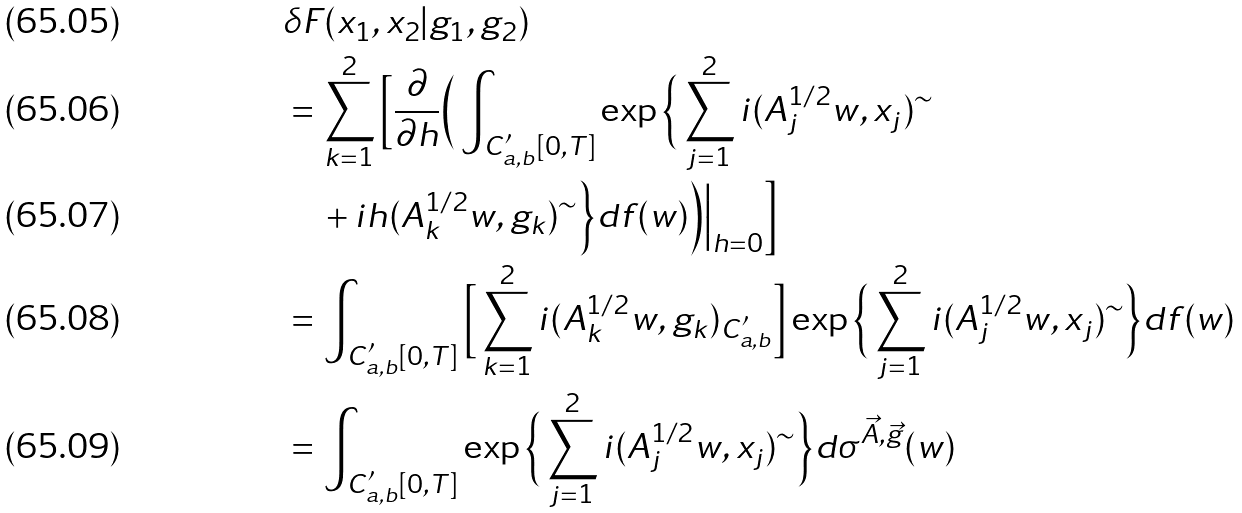Convert formula to latex. <formula><loc_0><loc_0><loc_500><loc_500>& \delta F ( x _ { 1 } , x _ { 2 } | g _ { 1 } , g _ { 2 } ) \\ & = \sum _ { k = 1 } ^ { 2 } \Big [ \frac { \partial } { \partial h } \Big ( \int _ { C _ { a , b } ^ { \prime } [ 0 , T ] } \exp \Big \{ \sum _ { j = 1 } ^ { 2 } i ( A _ { j } ^ { 1 / 2 } w , x _ { j } ) ^ { \sim } \\ & \quad + i h ( A _ { k } ^ { 1 / 2 } w , g _ { k } ) ^ { \sim } \Big \} d f ( w ) \Big ) \Big | _ { h = 0 } \Big ] \\ & = \int _ { C _ { a , b } ^ { \prime } [ 0 , T ] } \Big [ \sum _ { k = 1 } ^ { 2 } i ( A _ { k } ^ { 1 / 2 } w , g _ { k } ) _ { C _ { a , b } ^ { \prime } } \Big ] \exp \Big \{ \sum _ { j = 1 } ^ { 2 } i ( A _ { j } ^ { 1 / 2 } w , x _ { j } ) ^ { \sim } \Big \} d f ( w ) \\ & = \int _ { C _ { a , b } ^ { \prime } [ 0 , T ] } \exp \Big \{ \sum _ { j = 1 } ^ { 2 } i ( A _ { j } ^ { 1 / 2 } w , x _ { j } ) ^ { \sim } \Big \} d \sigma ^ { \vec { A } , \vec { g } } ( w )</formula> 